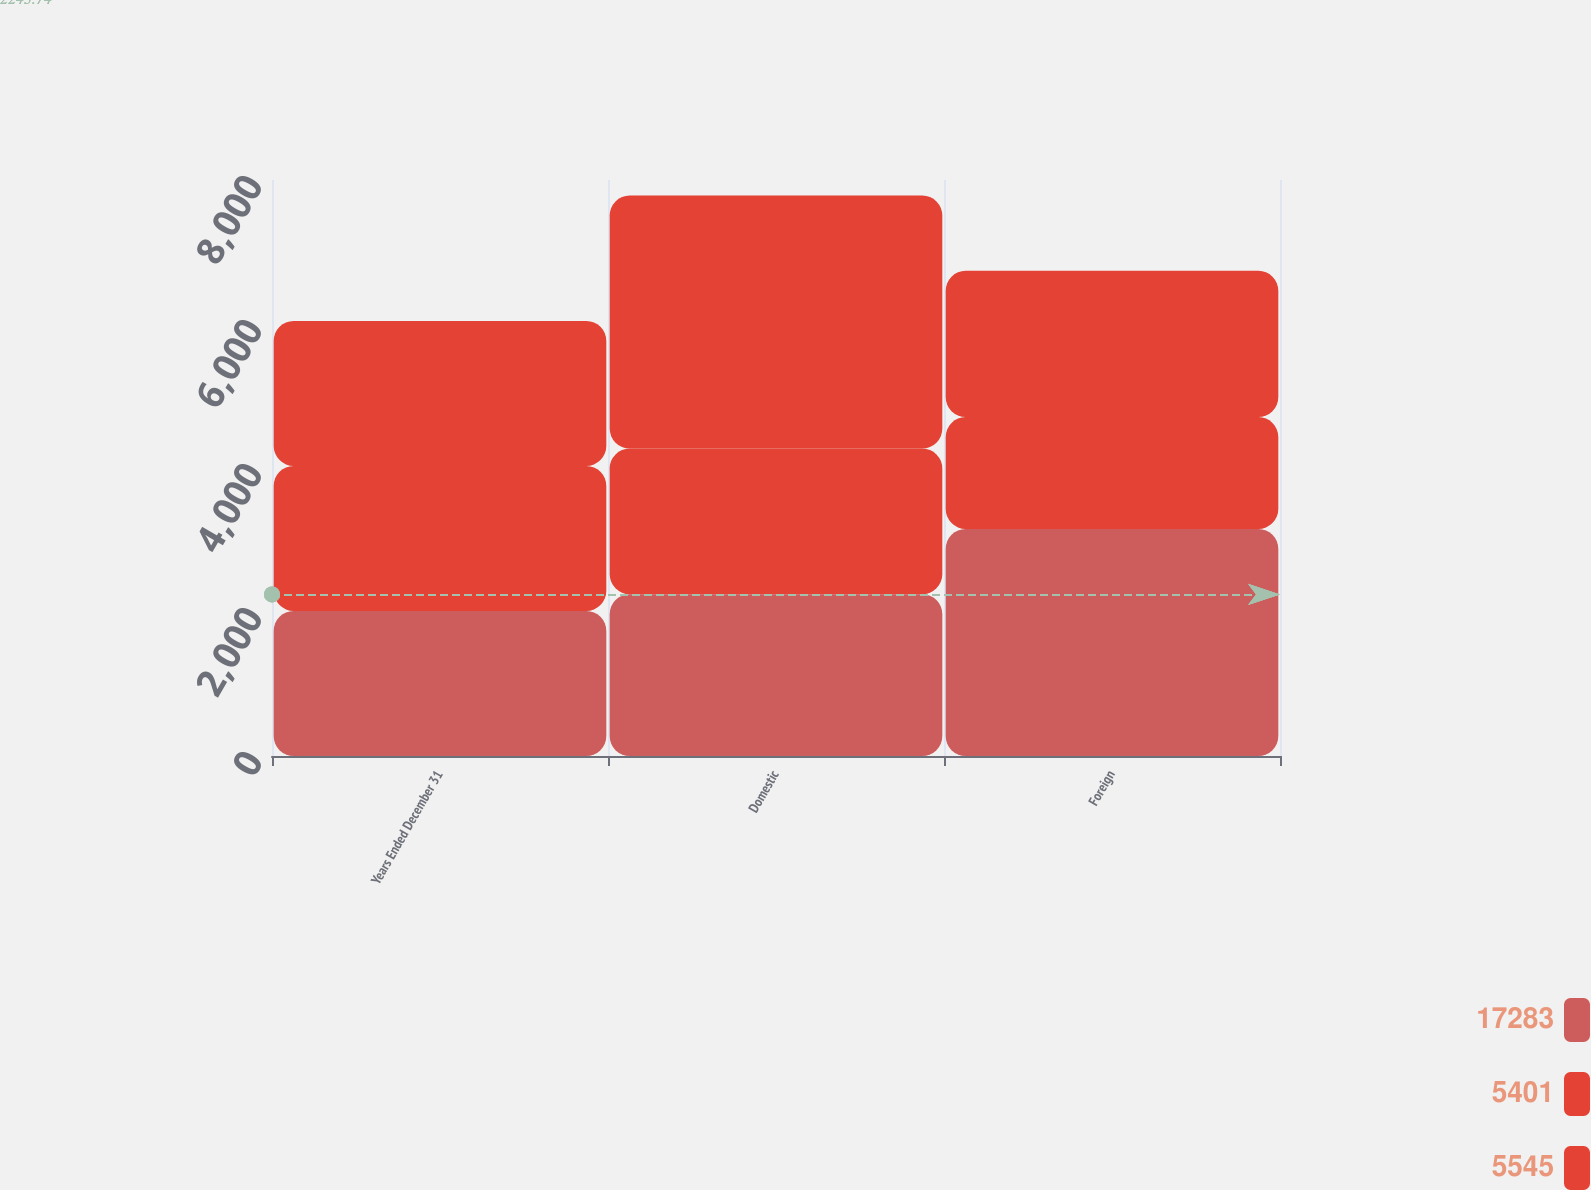Convert chart. <chart><loc_0><loc_0><loc_500><loc_500><stacked_bar_chart><ecel><fcel>Years Ended December 31<fcel>Domestic<fcel>Foreign<nl><fcel>17283<fcel>2015<fcel>2247<fcel>3154<nl><fcel>5401<fcel>2014<fcel>2023.5<fcel>1553<nl><fcel>5545<fcel>2013<fcel>3513<fcel>2032<nl></chart> 